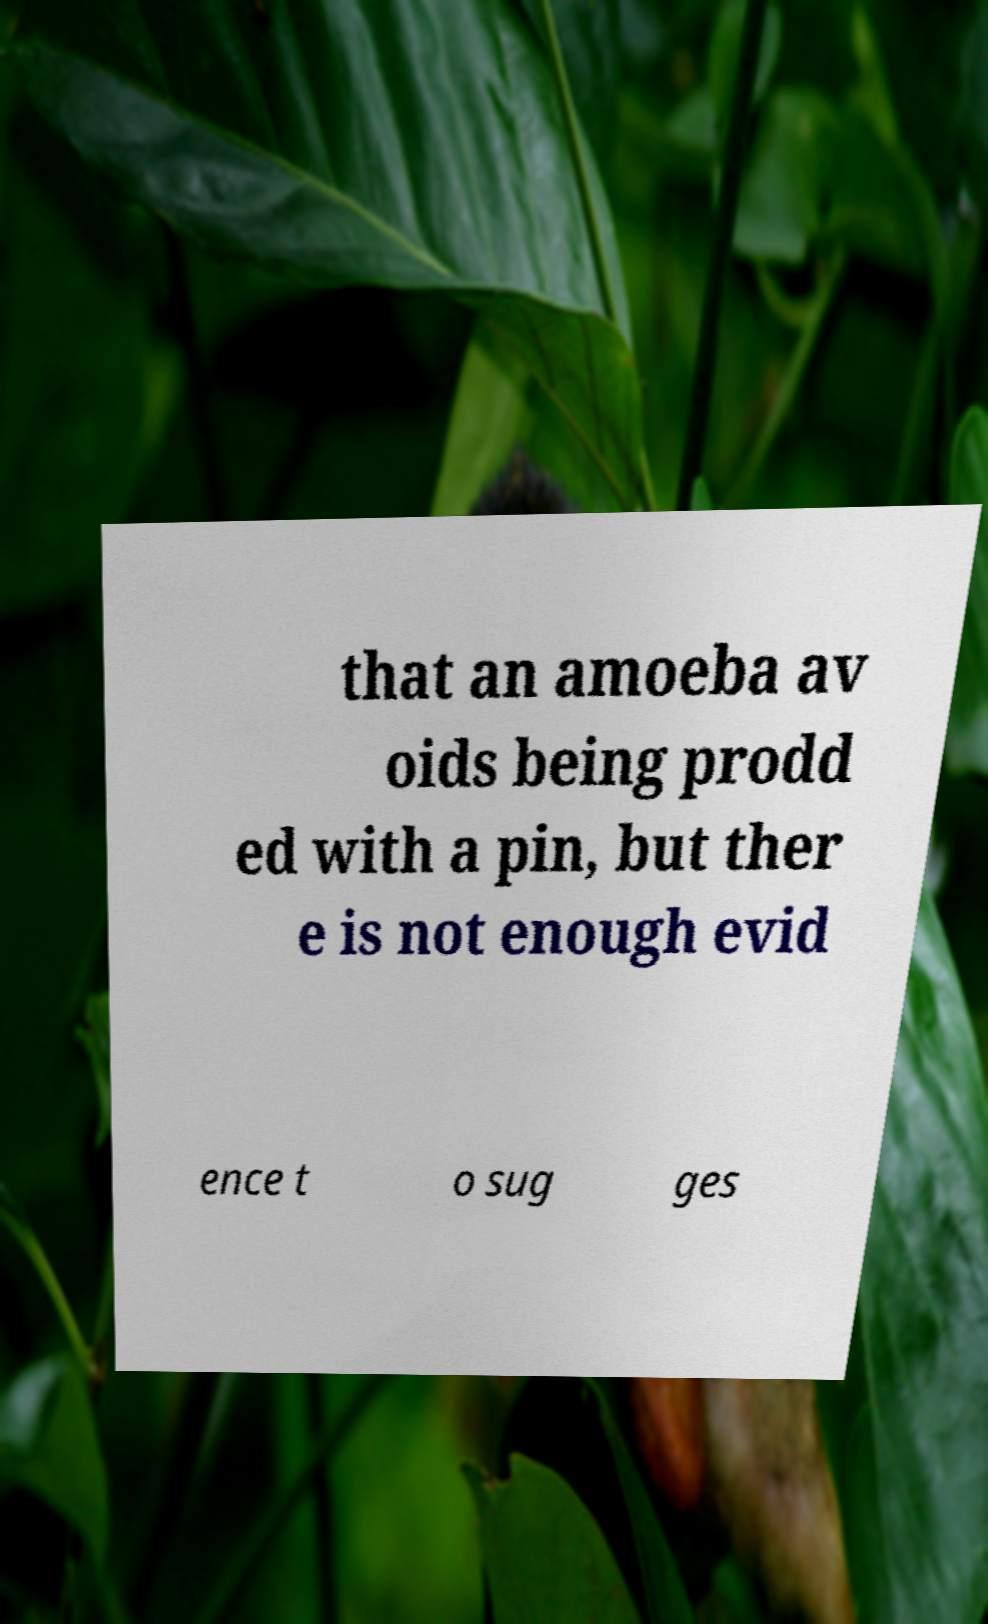I need the written content from this picture converted into text. Can you do that? that an amoeba av oids being prodd ed with a pin, but ther e is not enough evid ence t o sug ges 